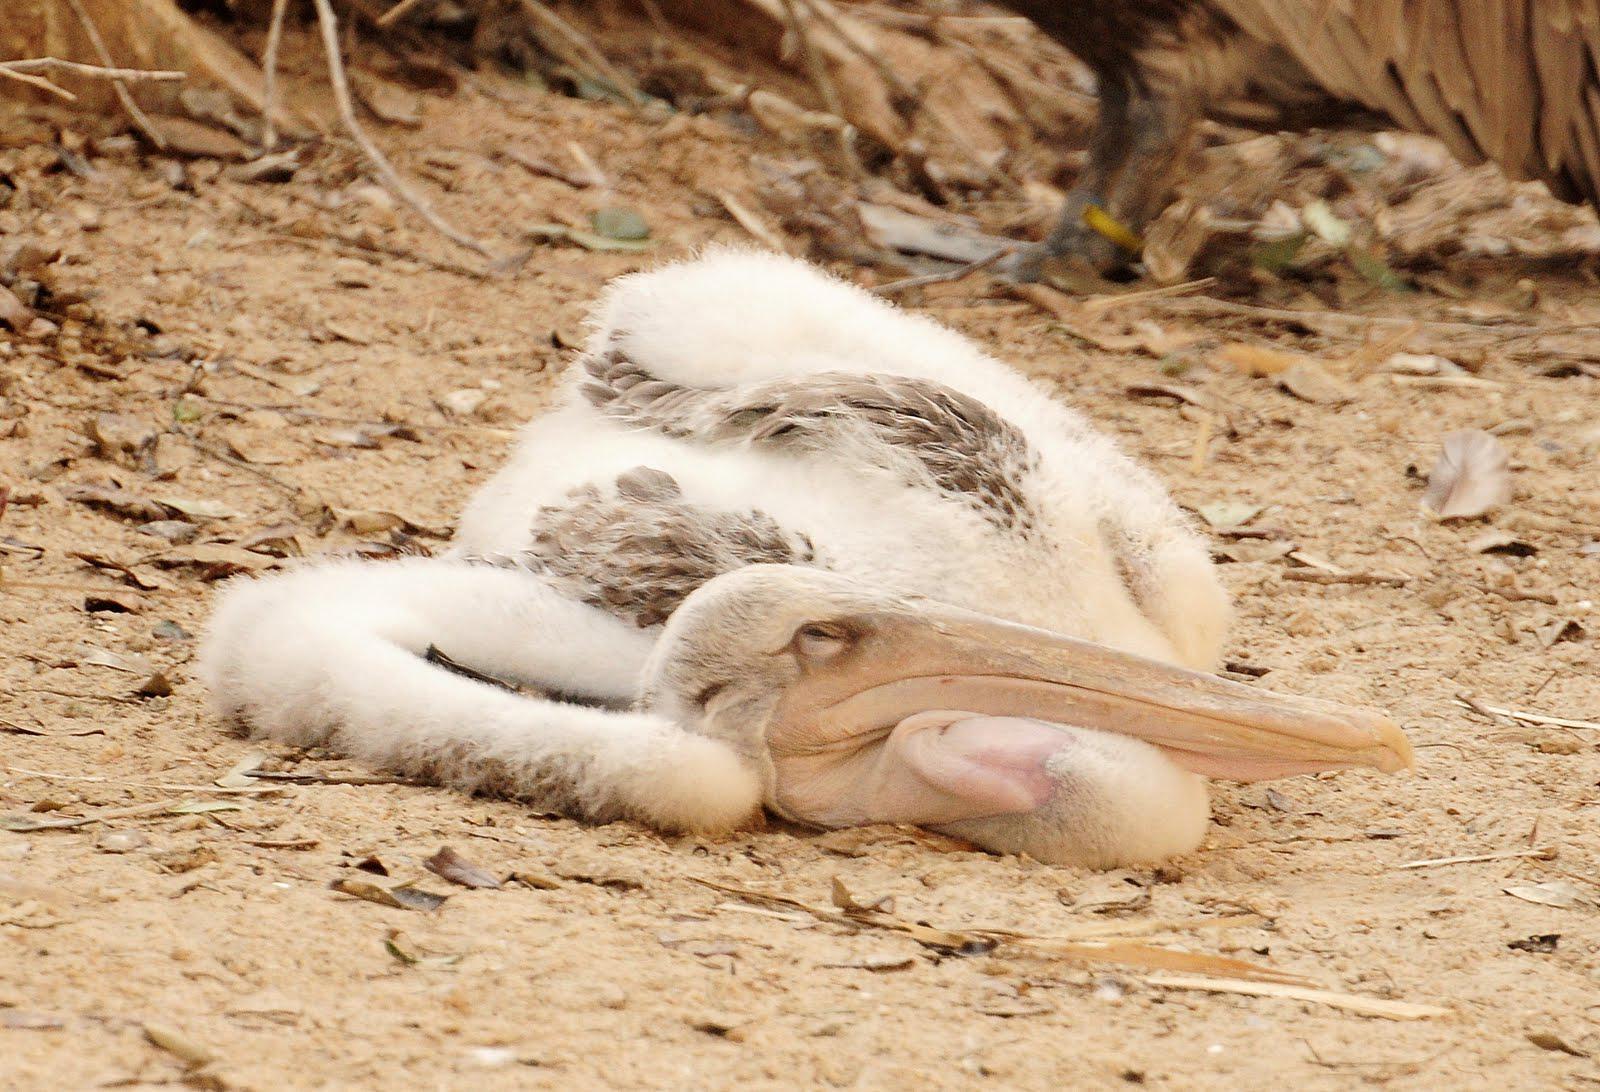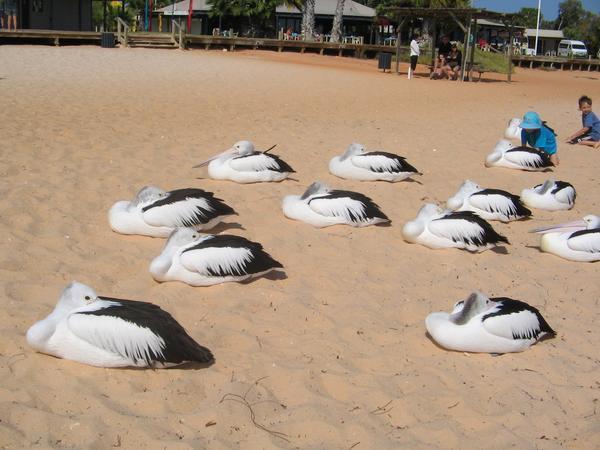The first image is the image on the left, the second image is the image on the right. For the images displayed, is the sentence "The left image contains no more than one bird." factually correct? Answer yes or no. Yes. The first image is the image on the left, the second image is the image on the right. For the images displayed, is the sentence "One image shows one non-standing white pelican, and the other image shows multiple black and white pelicans." factually correct? Answer yes or no. Yes. 